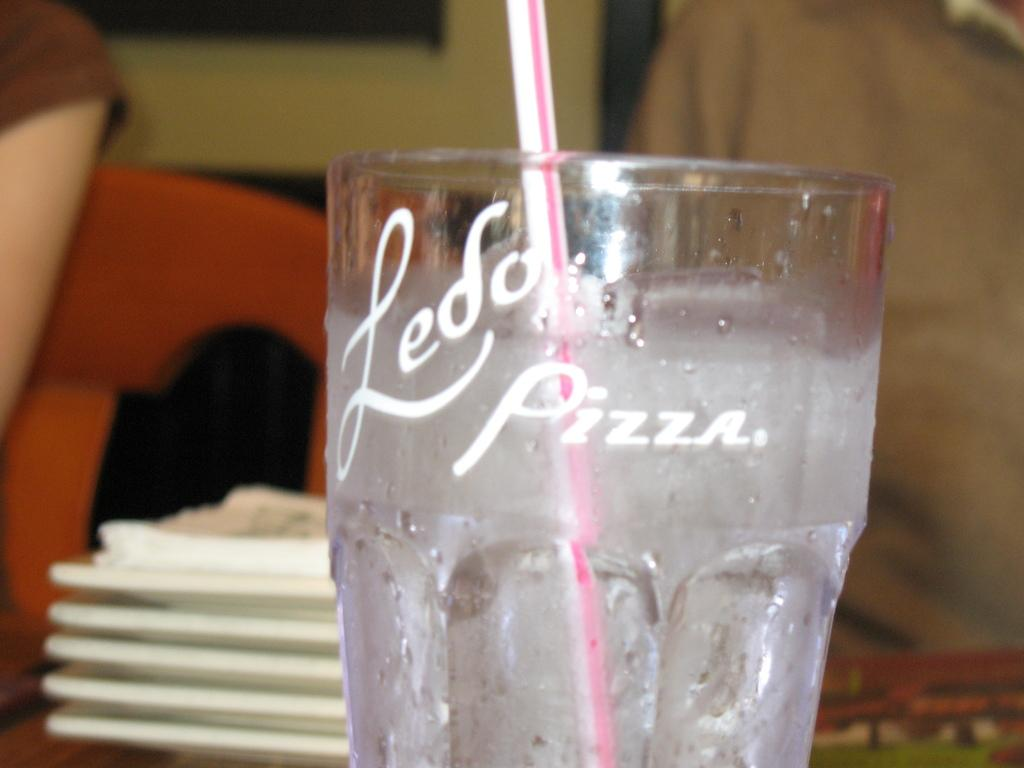<image>
Present a compact description of the photo's key features. A glass from Ledo Pizza holds a clear liquid and a straw. 